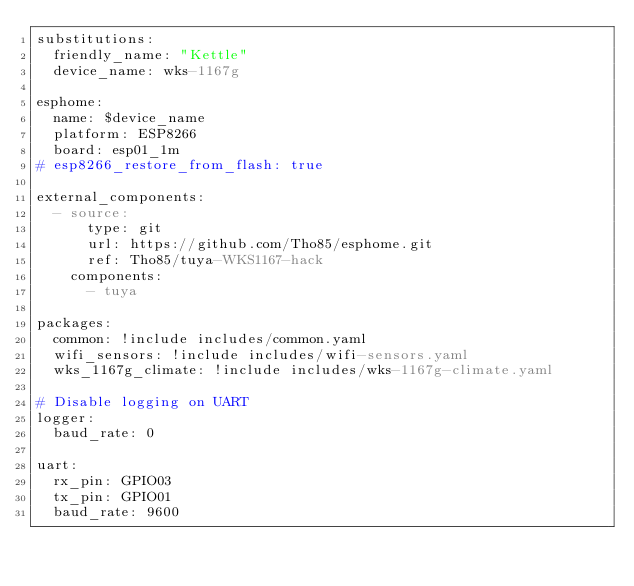Convert code to text. <code><loc_0><loc_0><loc_500><loc_500><_YAML_>substitutions:
  friendly_name: "Kettle"
  device_name: wks-1167g

esphome:
  name: $device_name
  platform: ESP8266
  board: esp01_1m
# esp8266_restore_from_flash: true

external_components:
  - source:
      type: git
      url: https://github.com/Tho85/esphome.git
      ref: Tho85/tuya-WKS1167-hack
    components:
      - tuya

packages:
  common: !include includes/common.yaml
  wifi_sensors: !include includes/wifi-sensors.yaml
  wks_1167g_climate: !include includes/wks-1167g-climate.yaml

# Disable logging on UART
logger:
  baud_rate: 0

uart:
  rx_pin: GPIO03
  tx_pin: GPIO01
  baud_rate: 9600
</code> 